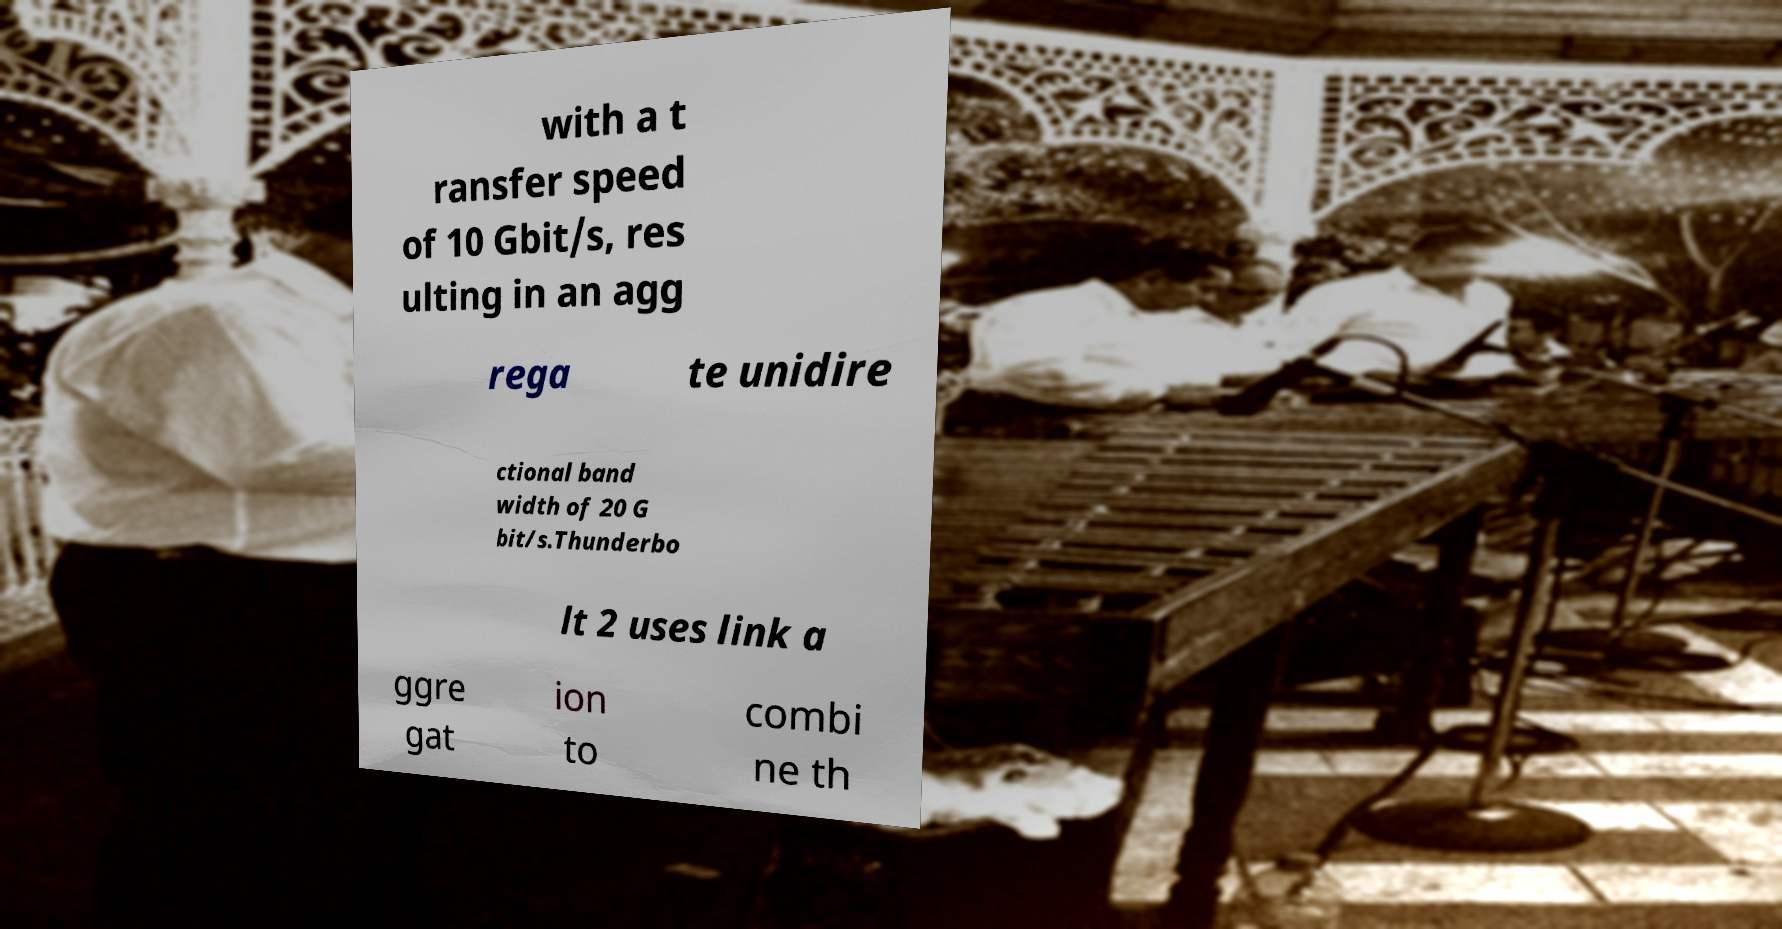Can you accurately transcribe the text from the provided image for me? with a t ransfer speed of 10 Gbit/s, res ulting in an agg rega te unidire ctional band width of 20 G bit/s.Thunderbo lt 2 uses link a ggre gat ion to combi ne th 